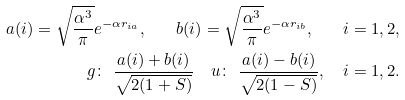<formula> <loc_0><loc_0><loc_500><loc_500>a ( i ) = \sqrt { \frac { \alpha ^ { 3 } } \pi } e ^ { - \alpha r _ { i a } } , \quad b ( i ) = \sqrt { \frac { \alpha ^ { 3 } } \pi } e ^ { - \alpha r _ { i b } } , \quad i = 1 , 2 , \\ g \colon \ \frac { a ( i ) + b ( i ) } { \sqrt { 2 ( 1 + S ) } } \quad u \colon \ \frac { a ( i ) - b ( i ) } { \sqrt { 2 ( 1 - S ) } } , \quad i = 1 , 2 .</formula> 